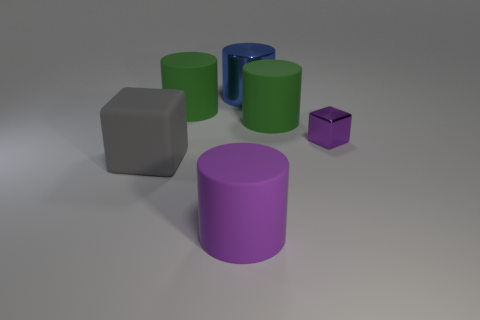Add 2 tiny purple matte cubes. How many objects exist? 8 Subtract all cylinders. How many objects are left? 2 Subtract all purple shiny objects. Subtract all big green matte cylinders. How many objects are left? 3 Add 2 small purple metallic things. How many small purple metallic things are left? 3 Add 3 things. How many things exist? 9 Subtract 0 gray balls. How many objects are left? 6 